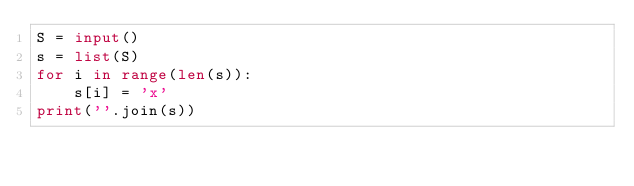<code> <loc_0><loc_0><loc_500><loc_500><_Python_>S = input()
s = list(S)
for i in range(len(s)):
    s[i] = 'x'
print(''.join(s))</code> 